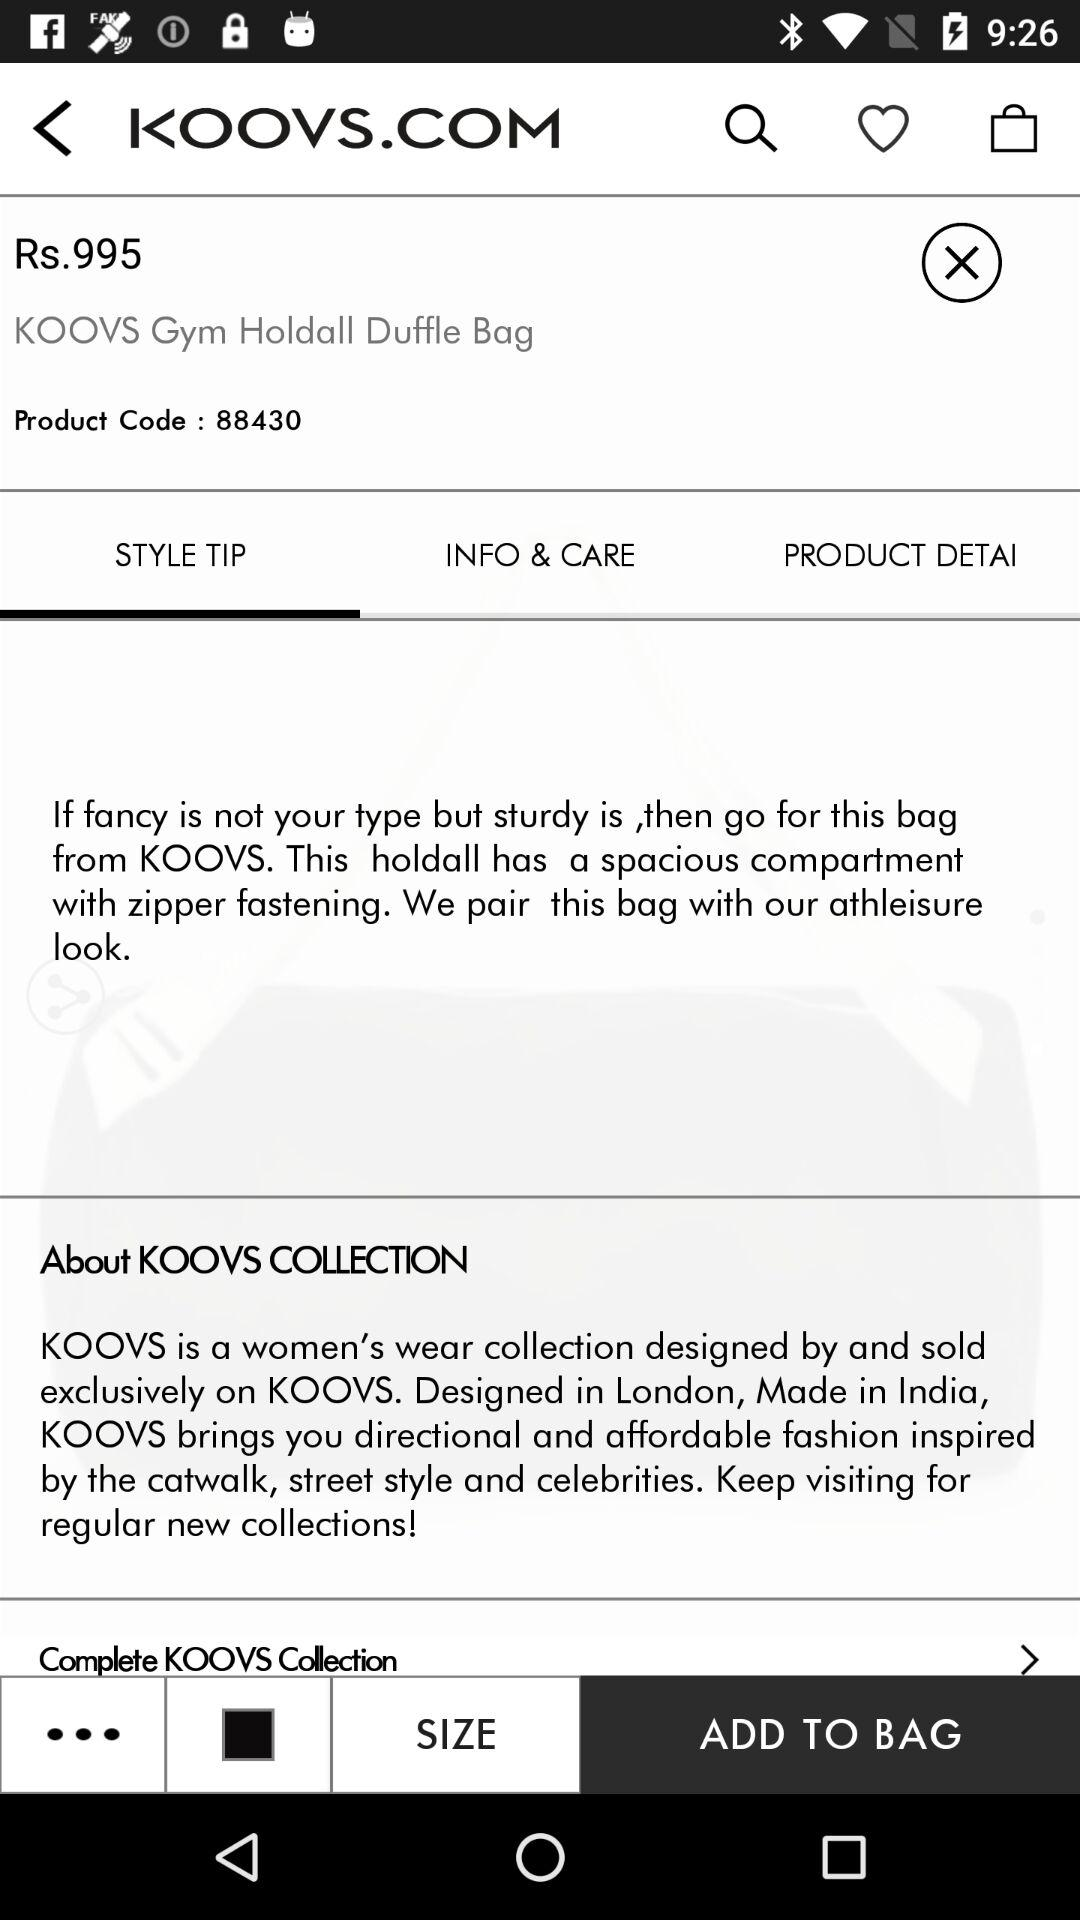How much is the KOOVS Gym Holdall Duffle Bag?
Answer the question using a single word or phrase. Rs.995 